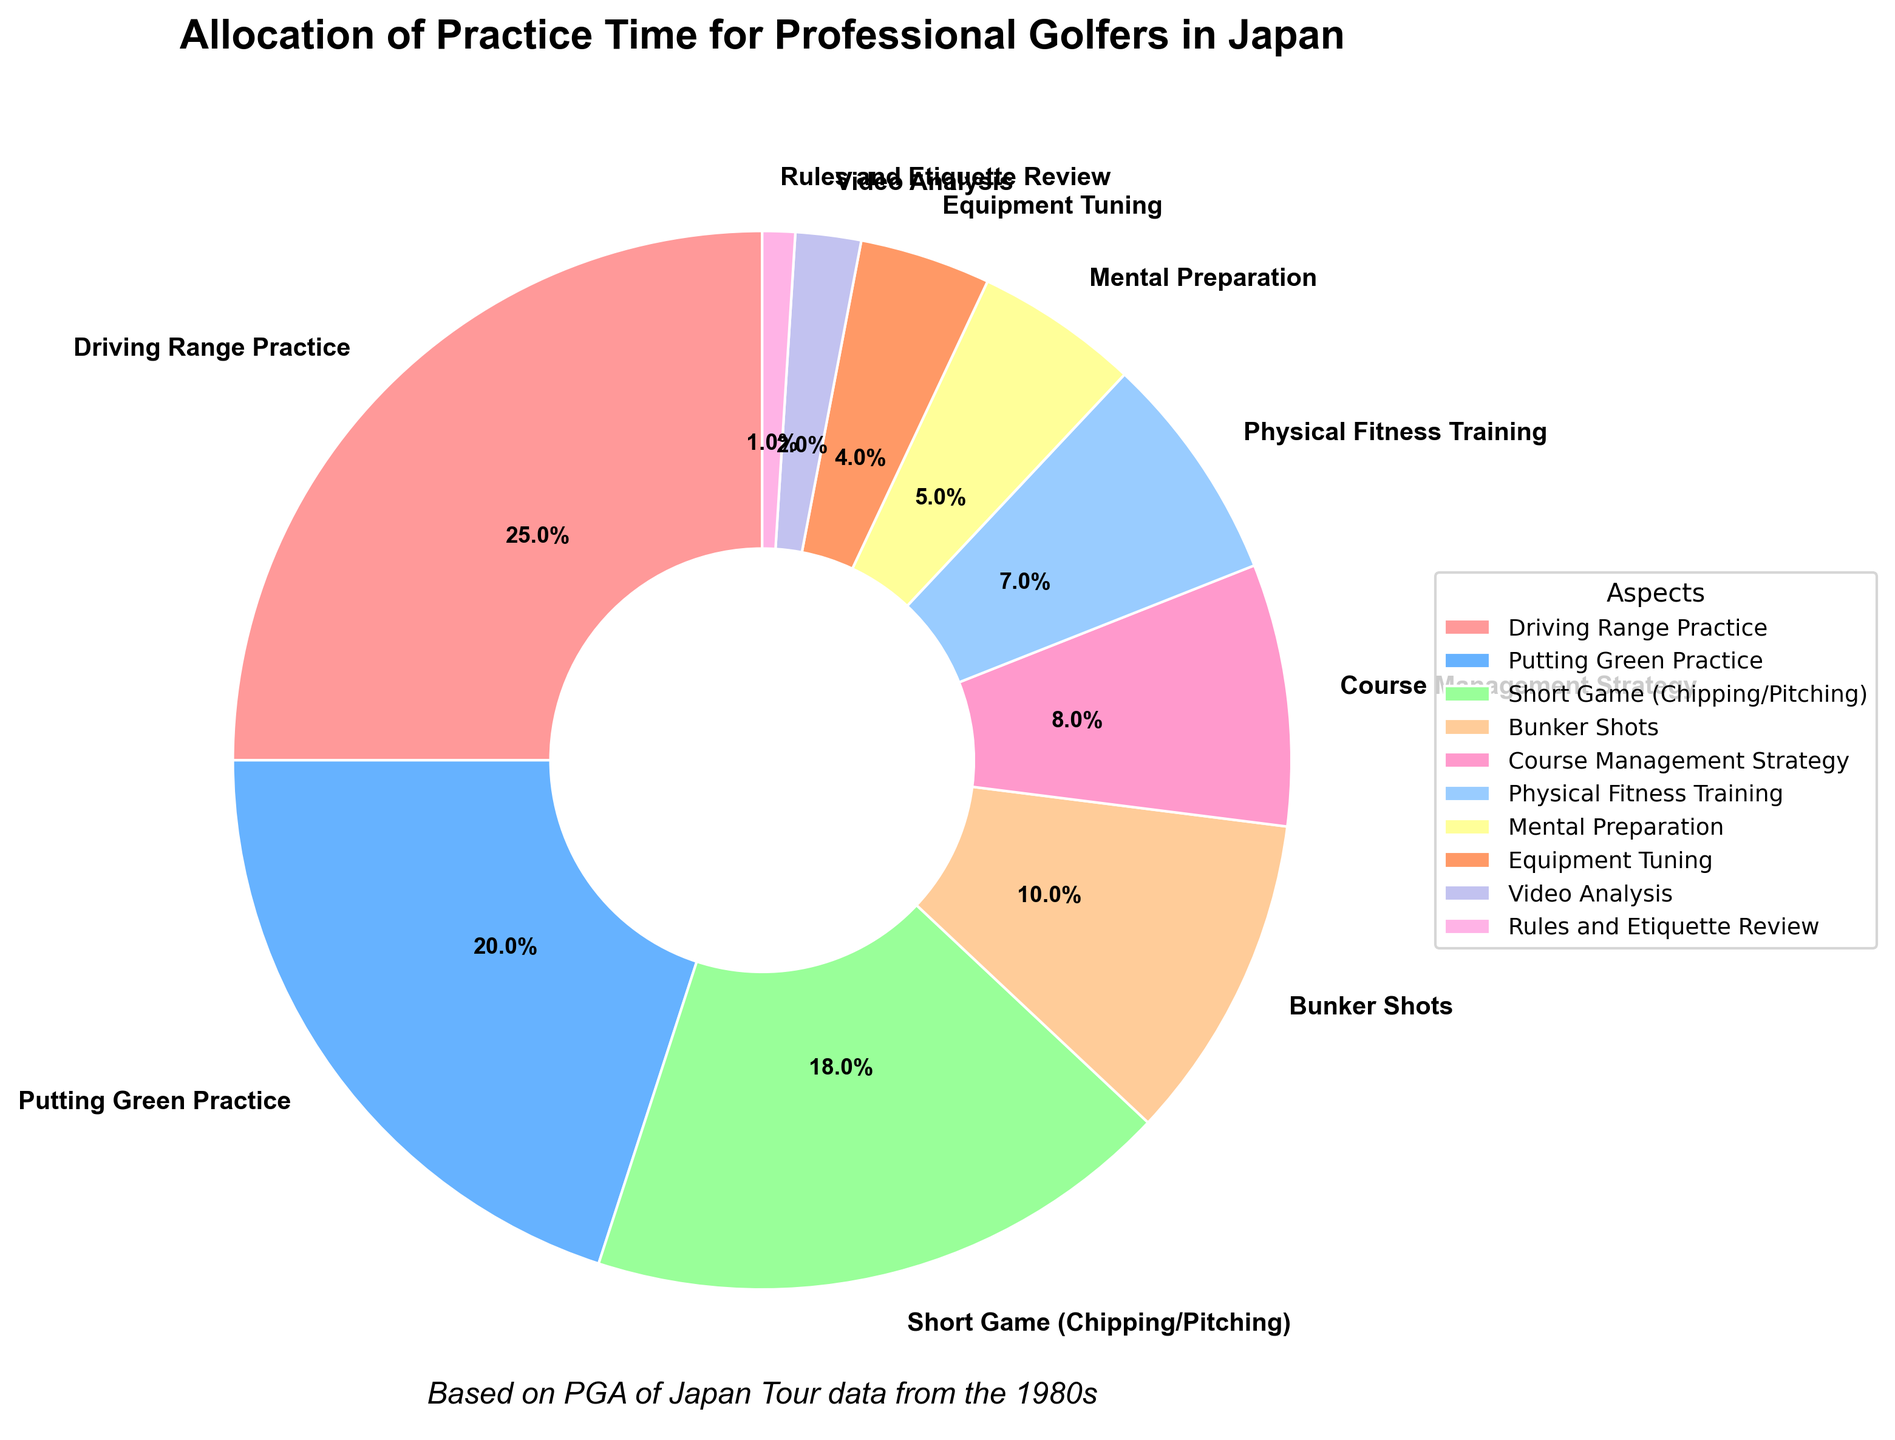what percentage of practice time is allocated to mental preparation and equipment tuning combined? To get the total percentage of practice time for mental preparation and equipment tuning, add their individual percentages: 5% for mental preparation + 4% for equipment tuning = 9%.
Answer: 9% Which aspect of practice is given the highest percentage of allocation? By examining the pie chart, the largest slice represents Driving Range Practice with 25% of the practice time.
Answer: Driving Range Practice What is the difference in the percentage of time allocated between putting green practice and physical fitness training? Subtract the percentage of physical fitness training (7%) from the percentage of putting green practice (20%): 20% - 7% = 13%.
Answer: 13% Which has a larger allocation, short game practice or bunker shots, and by how much? Short game practice has 18%, and bunker shots have 10%. Subtract 10% from 18% to find that short game practice has a larger allocation by 8%.
Answer: Short game practice by 8% Are the allocations for video analysis and rules and etiquette review combined greater than or equal to the allocation for course management strategy? Video analysis has 2%, and rules and etiquette review has 1%. Combined, this sums to 3%. Course management strategy is allocated 8%. Since 3% is less than 8%, the combined allocation is less than that of course management strategy.
Answer: No, less than What percentage of practice time is allocated to short game (chipping/pitching) and bunker shots combined relative to the total allocation? Add these two percentages: 18% for short game and 10% for bunker shots. The combined percentage is 28%.
Answer: 28% Which aspect has the smallest allocation, and what is its percentage? The smallest slice of the pie chart represents Rules and Etiquette Review with a percentage of 1%.
Answer: Rules and Etiquette Review, 1% What's the combined percentage of practice time allocated to physical fitness training and mental preparation? Add the percentage of physical fitness training (7%) and mental preparation (5%) to get a combined total of 12%.
Answer: 12% Which aspect is represented by the green color, and what is its percentage? The green slice of the pie chart represents Short Game (Chipping/Pitching), which has an allocation percentage of 18%.
Answer: Short Game (Chipping/Pitching), 18% How does the percentage of putting green practice compare to course management strategy and bunker shots combined? The percentage for putting green practice is 20%. Combined, course management strategy has 8% and bunker shots have 10%, yielding 18%. Since 20% is greater than 18%, the percentage for putting green practice is larger.
Answer: Putting green practice is larger 